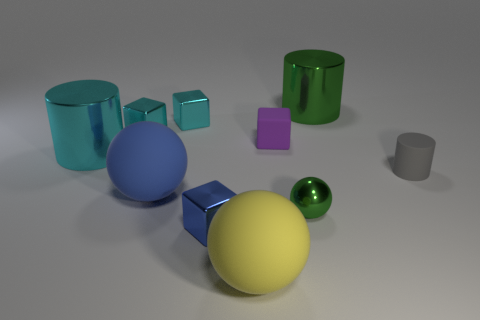What different materials do the objects in the image seem to be made of? Some objects in the image appear to be made of reflective metallic material, such as the green and yellow balls, and the blue cube. Others seem to have a matte finish, like the purple block and the gray cup, indicating a less reflective material, possibly plastic or ceramic. 